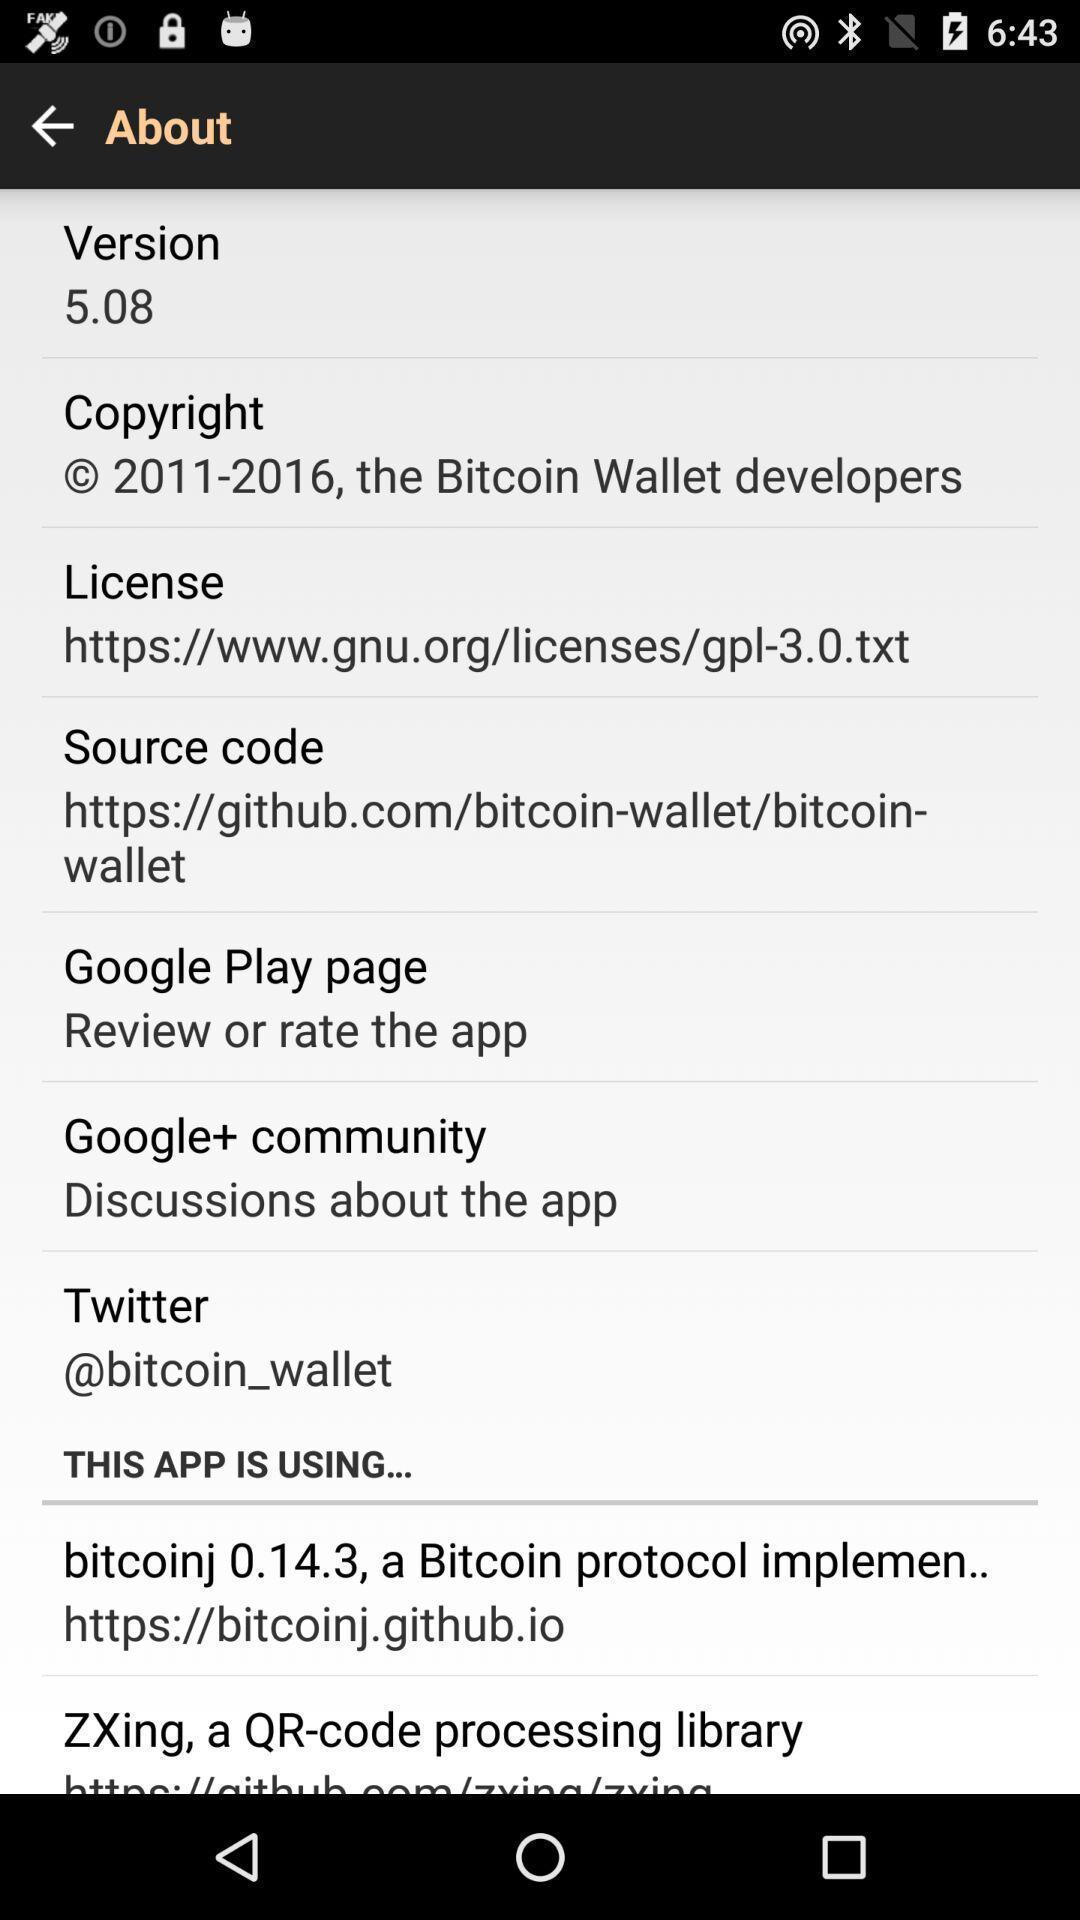Give me a summary of this screen capture. Page showing description about an app. 